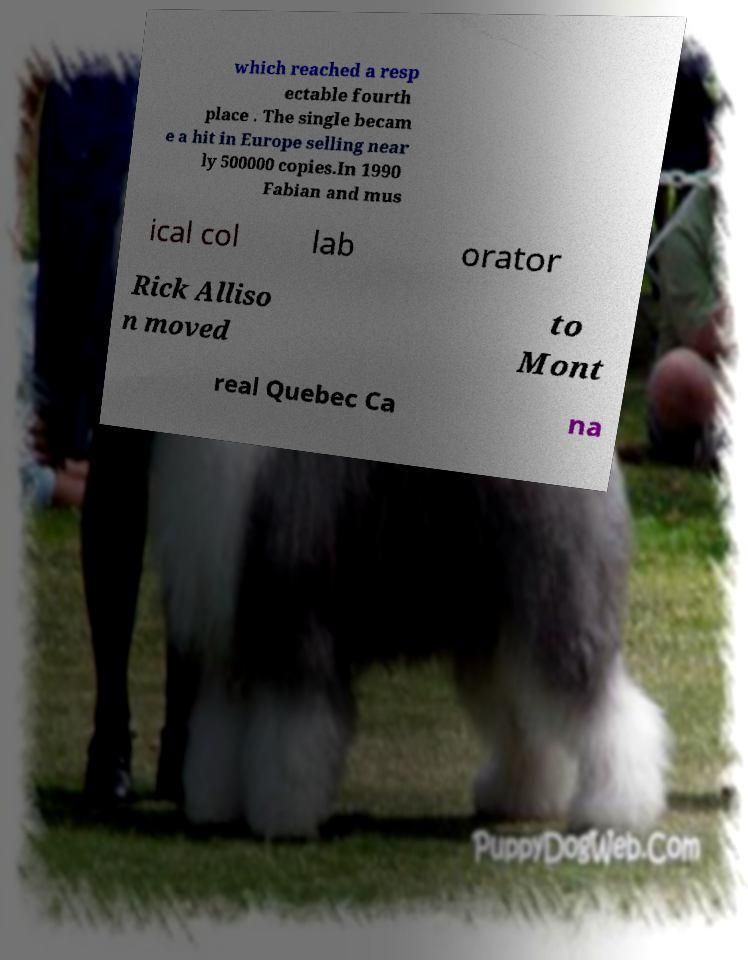What messages or text are displayed in this image? I need them in a readable, typed format. which reached a resp ectable fourth place . The single becam e a hit in Europe selling near ly 500000 copies.In 1990 Fabian and mus ical col lab orator Rick Alliso n moved to Mont real Quebec Ca na 